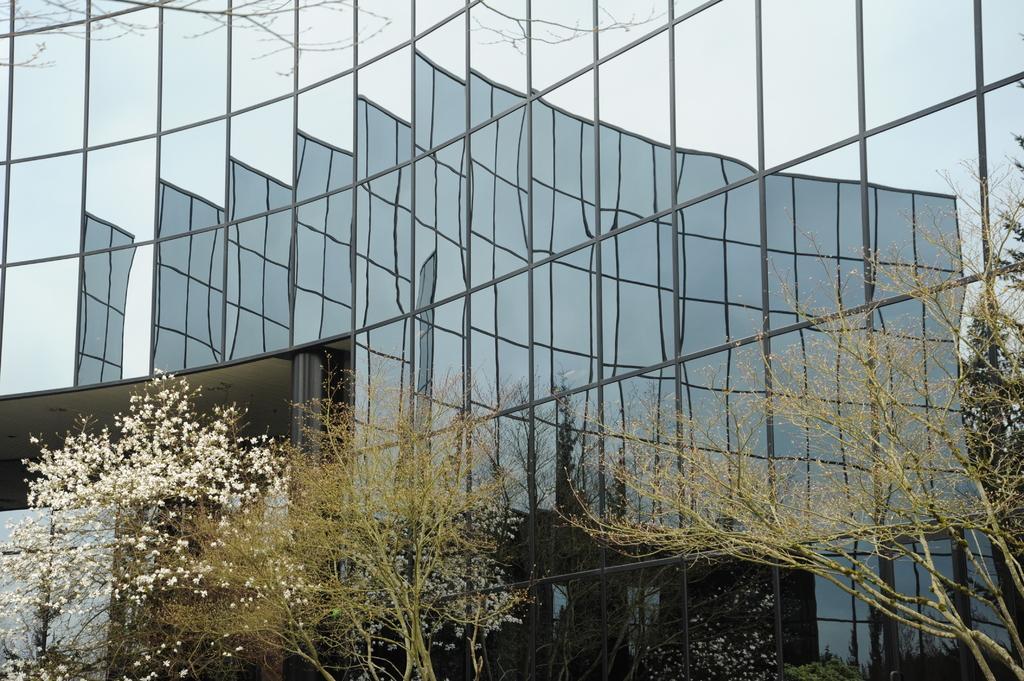Can you describe this image briefly? In the picture I can see framed glass wall, trees, a building and the sky. 